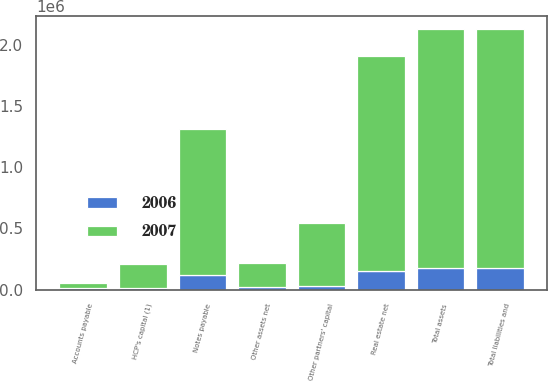<chart> <loc_0><loc_0><loc_500><loc_500><stacked_bar_chart><ecel><fcel>Real estate net<fcel>Other assets net<fcel>Total assets<fcel>Notes payable<fcel>Accounts payable<fcel>Other partners' capital<fcel>HCP's capital (1)<fcel>Total liabilities and<nl><fcel>2007<fcel>1.75229e+06<fcel>195816<fcel>1.9481e+06<fcel>1.19227e+06<fcel>45427<fcel>511149<fcel>199259<fcel>1.9481e+06<nl><fcel>2006<fcel>150206<fcel>25358<fcel>175564<fcel>116805<fcel>13690<fcel>32549<fcel>12520<fcel>175564<nl></chart> 